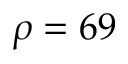Convert formula to latex. <formula><loc_0><loc_0><loc_500><loc_500>\rho = 6 9</formula> 